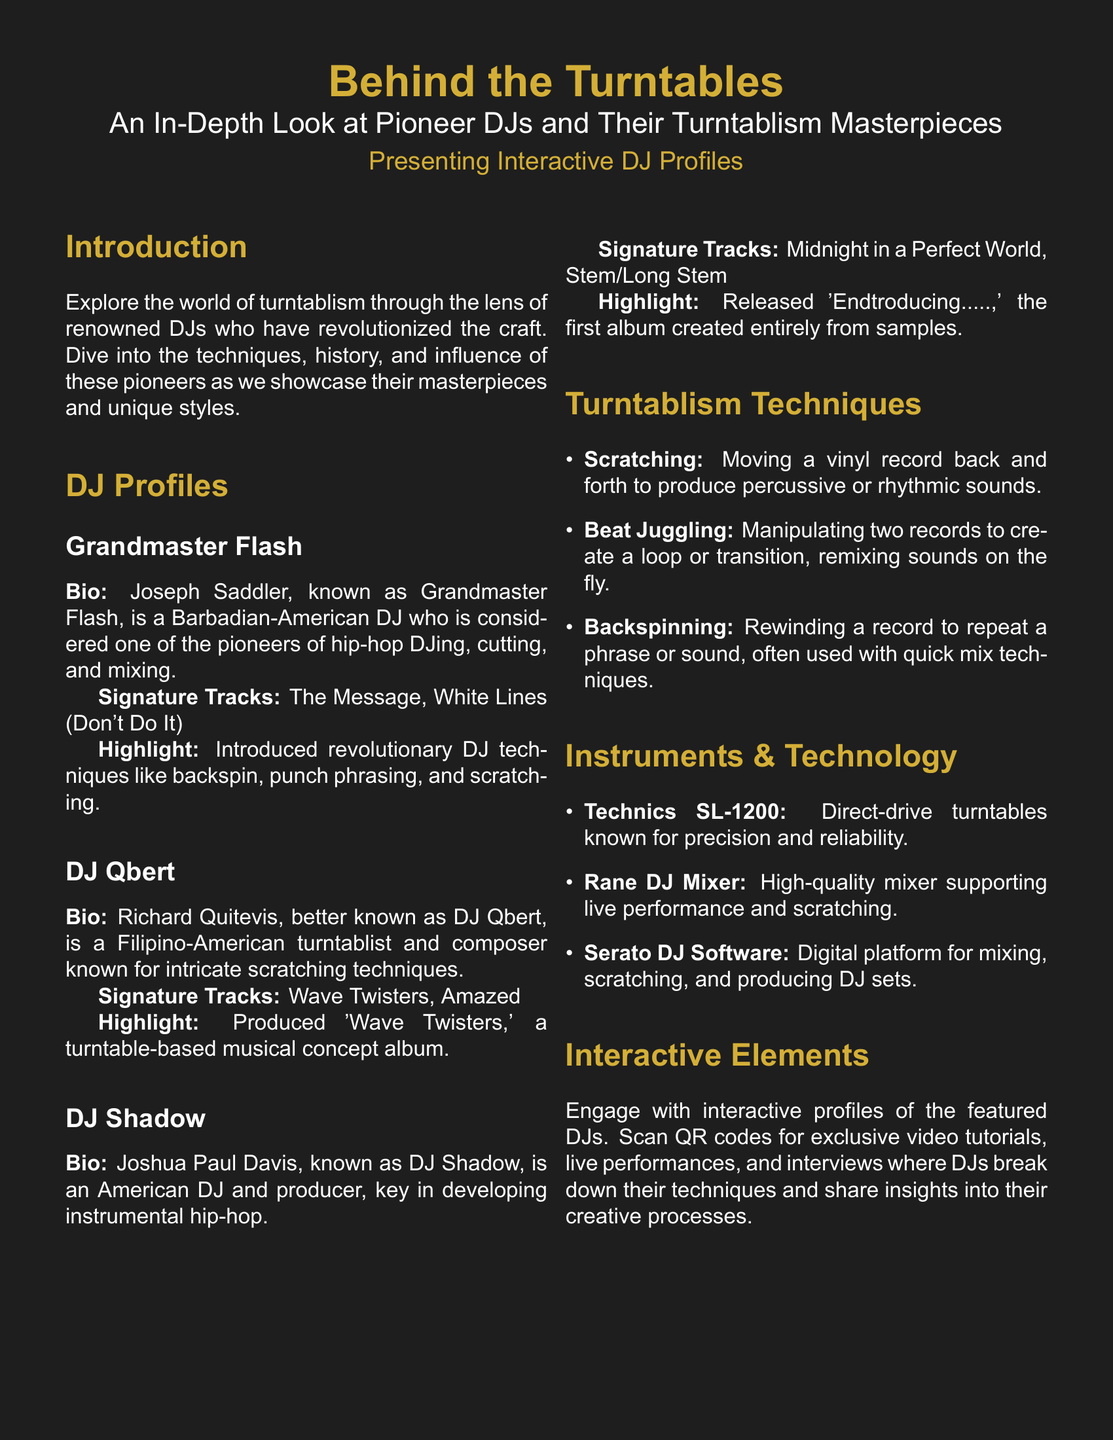What is the title of the document? The title is prominently displayed at the top of the document, highlighting the main theme of the event.
Answer: Behind the Turntables Who is known as the pioneer of hip-hop DJing? The document provides a specific DJ's name who is recognized for pioneering hip-hop DJing techniques.
Answer: Grandmaster Flash What did DJ Qbert produce that is mentioned in the document? The document refers to a specific album created by DJ Qbert that showcases his craftsmanship.
Answer: Wave Twisters What instrument is highlighted for its precision and reliability? The document identifies a specific turntable known for its quality, which is crucial for DJs.
Answer: Technics SL-1200 What technique involves moving a vinyl record back and forth? The document describes a foundational technique in turntablism, focusing on its percussive nature.
Answer: Scratching What is the highlight stated for DJ Shadow? The document includes a notable achievement of DJ Shadow that illustrates his impact on music.
Answer: Released 'Endtroducing.....' How many prominent DJ profiles are presented in the document? The document lists multiple profiles, providing insight into the number of featured DJs.
Answer: Three What technology is mentioned for live performance support? The document highlights a specific type of DJ mixer that aids in live performances.
Answer: Rane DJ Mixer What is a common interactive feature included in the document? The document mentions an interactive element that allows direct engagement with the DJs' work.
Answer: QR codes for exclusive video tutorials 